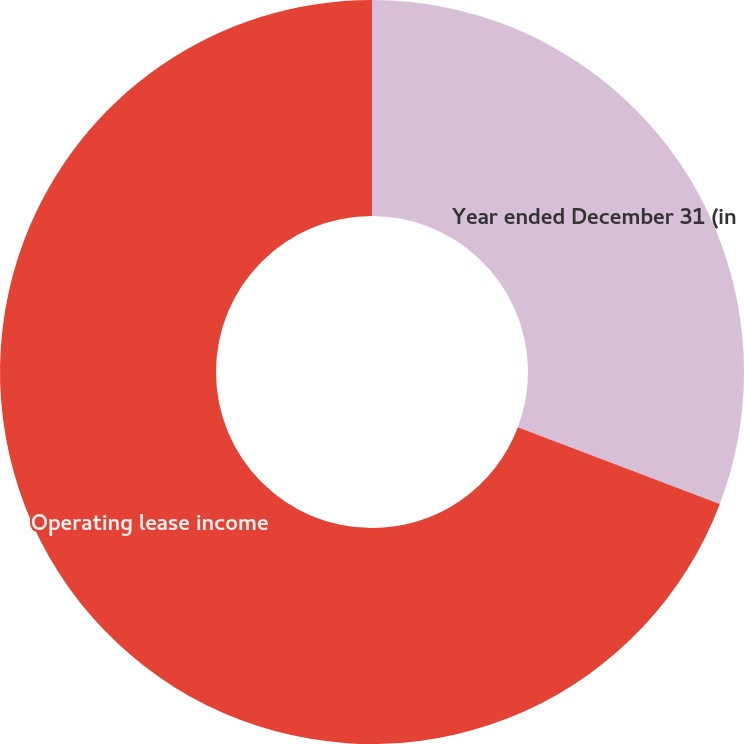<chart> <loc_0><loc_0><loc_500><loc_500><pie_chart><fcel>Year ended December 31 (in<fcel>Operating lease income<nl><fcel>30.77%<fcel>69.23%<nl></chart> 